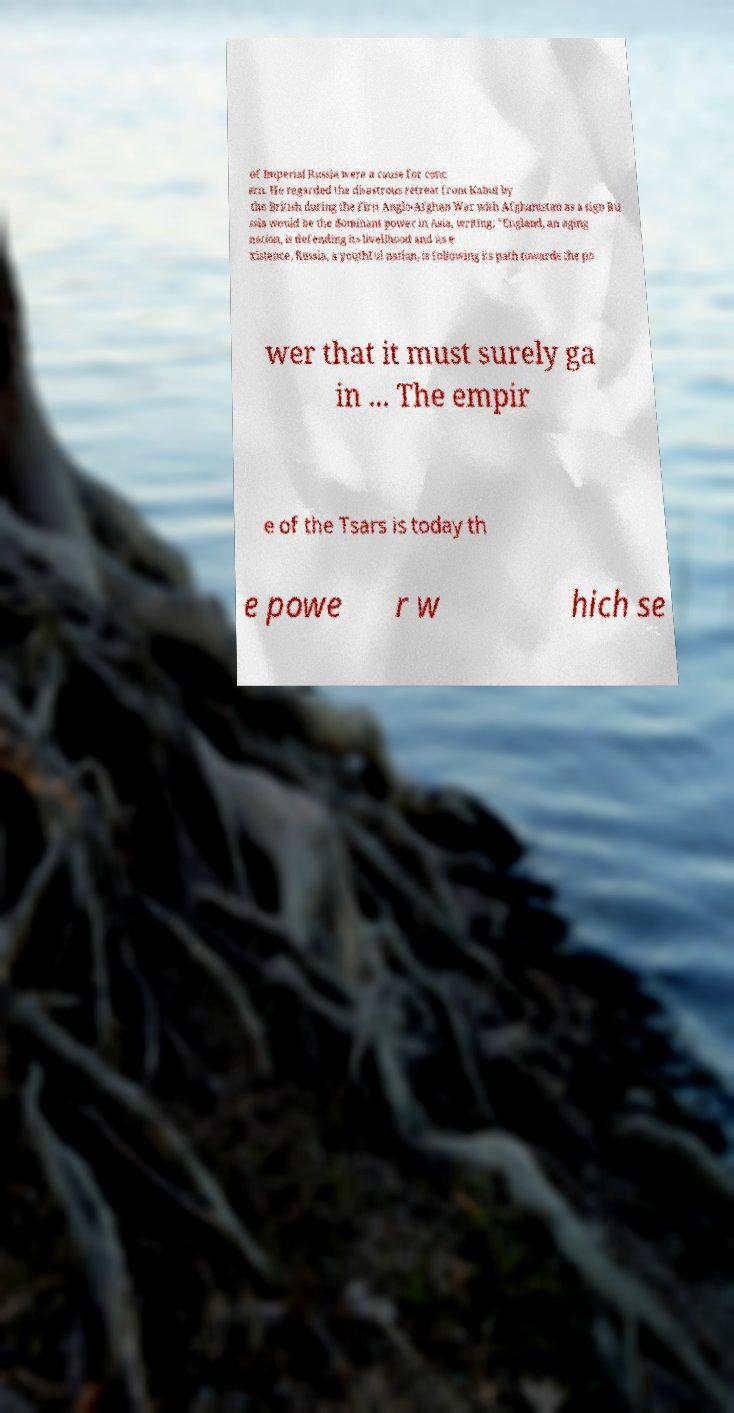Please identify and transcribe the text found in this image. of Imperial Russia were a cause for conc ern. He regarded the disastrous retreat from Kabul by the British during the First Anglo-Afghan War with Afghanistan as a sign Ru ssia would be the dominant power in Asia, writing: "England, an aging nation, is defending its livelihood and its e xistence. Russia, a youthful nation, is following its path towards the po wer that it must surely ga in ... The empir e of the Tsars is today th e powe r w hich se 